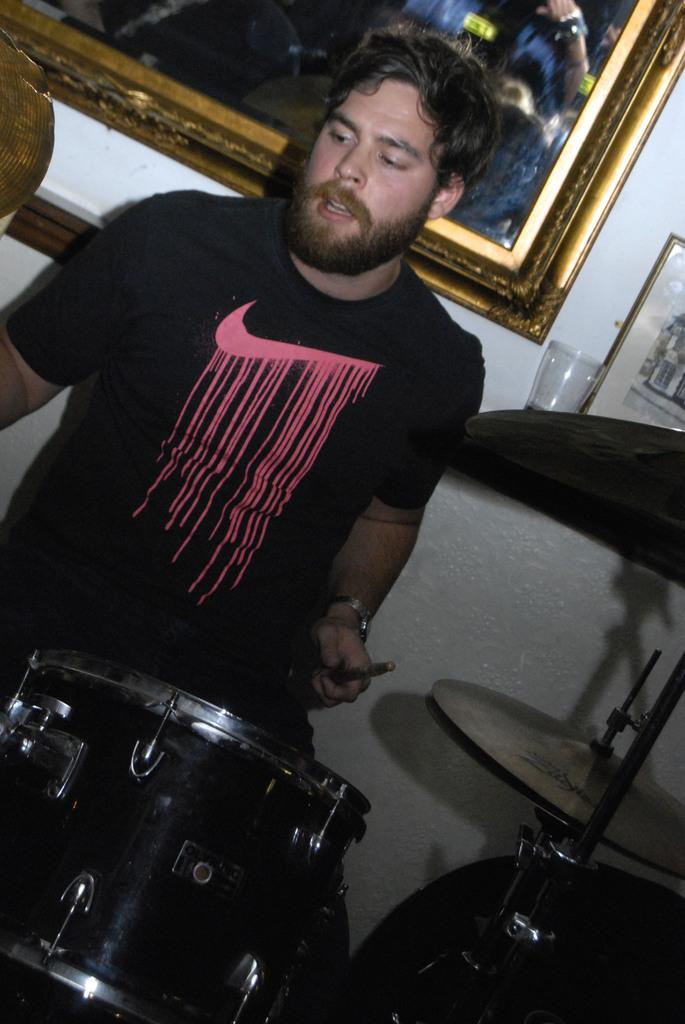What is the main subject of the image? There is a person in the image. What is the person wearing? The person is wearing a black dress. What activity is the person engaged in? The person is playing drums. What can be seen in the background of the image? There is a picture attached to the wall in the background. What type of wire can be seen connecting the person's teeth in the image? There is no wire connecting the person's teeth in the image, as they are playing drums and not wearing any dental apparatus. What kind of spark can be seen coming from the drumsticks in the image? There is no spark coming from the drumsticks in the image; they are simply being used to play the drums. 